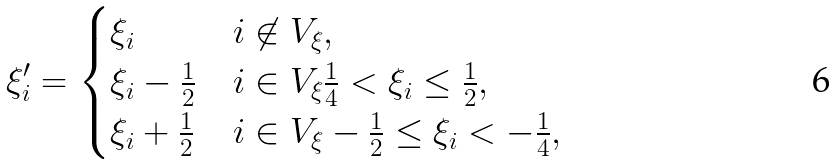Convert formula to latex. <formula><loc_0><loc_0><loc_500><loc_500>\xi ^ { \prime } _ { i } = \begin{cases} \xi _ { i } & i \not \in V _ { \xi } , \\ \xi _ { i } - \frac { 1 } { 2 } & i \in V _ { \xi } \frac { 1 } { 4 } < \xi _ { i } \leq \frac { 1 } { 2 } , \\ \xi _ { i } + \frac { 1 } { 2 } & i \in V _ { \xi } - \frac { 1 } { 2 } \leq \xi _ { i } < - \frac { 1 } { 4 } , \end{cases}</formula> 